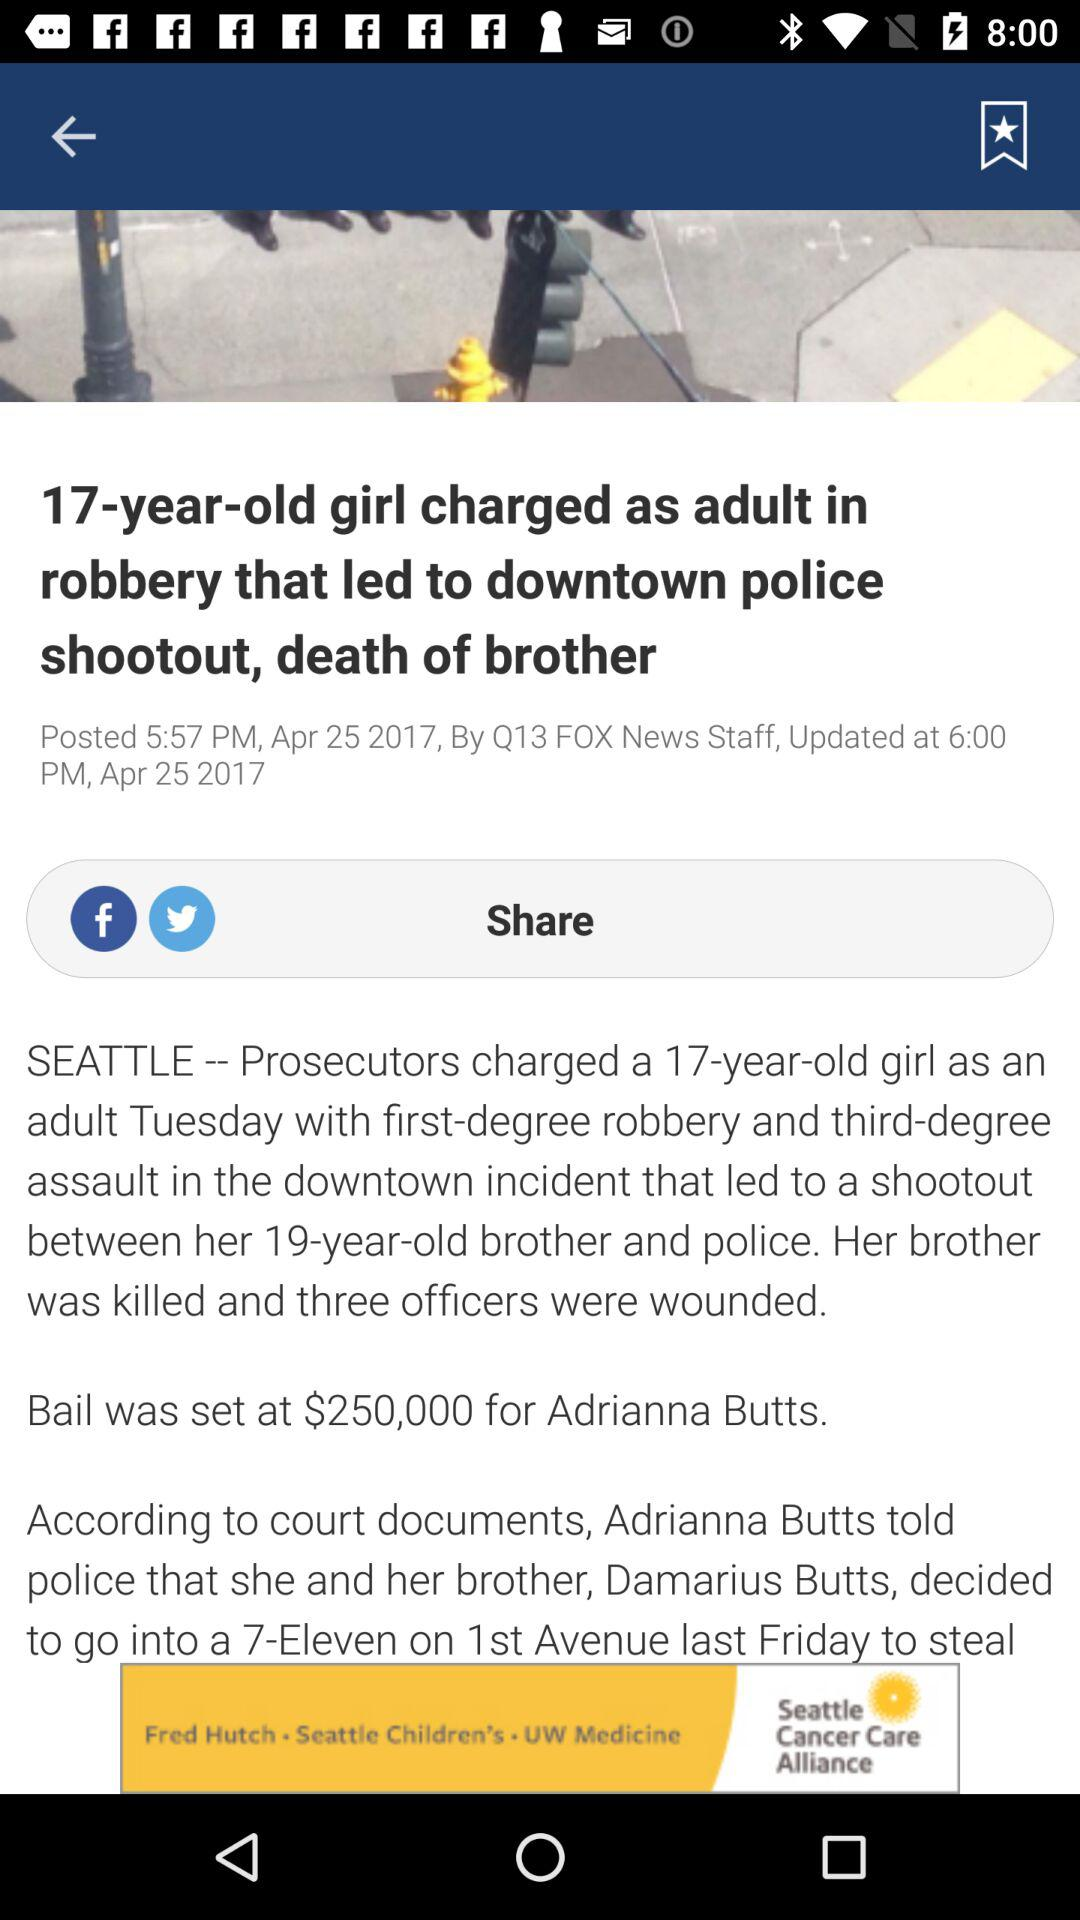Which applications can be used to share the news? The applications that can be used to share the news are "Facebook" and "Twitter". 